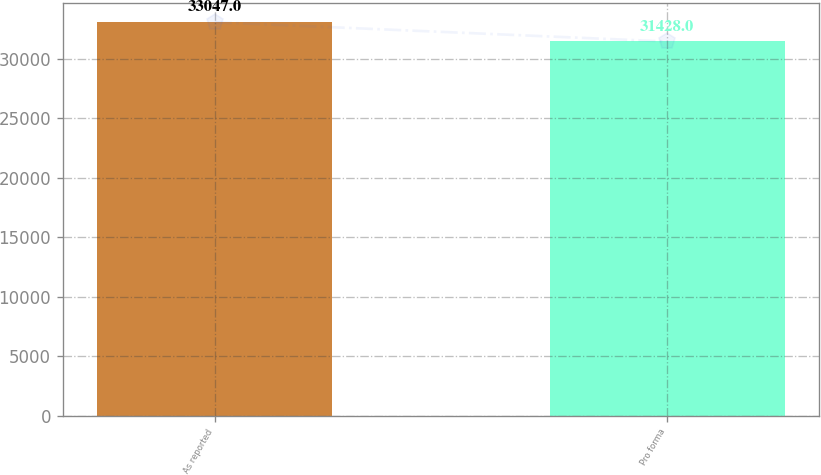<chart> <loc_0><loc_0><loc_500><loc_500><bar_chart><fcel>As reported<fcel>Pro forma<nl><fcel>33047<fcel>31428<nl></chart> 